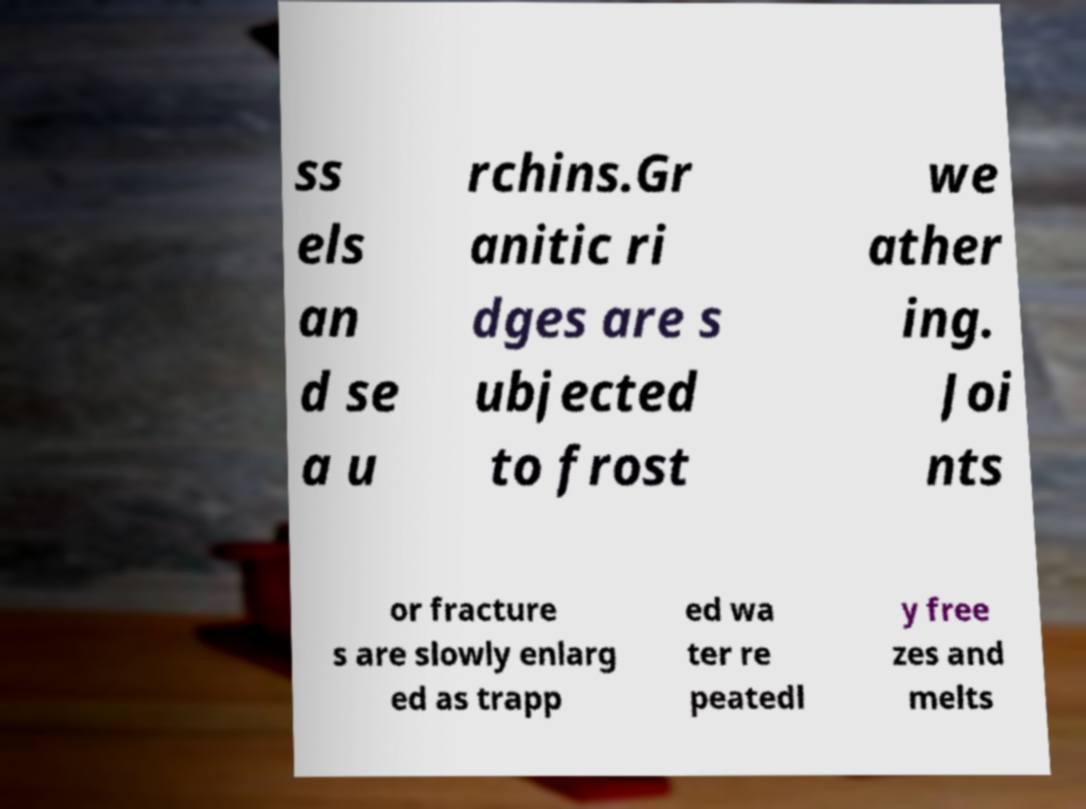I need the written content from this picture converted into text. Can you do that? ss els an d se a u rchins.Gr anitic ri dges are s ubjected to frost we ather ing. Joi nts or fracture s are slowly enlarg ed as trapp ed wa ter re peatedl y free zes and melts 